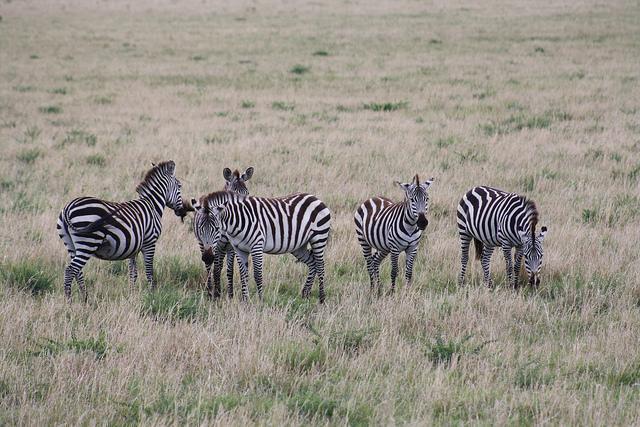How many zebras are standing in the middle of the open field?
Answer the question by selecting the correct answer among the 4 following choices and explain your choice with a short sentence. The answer should be formatted with the following format: `Answer: choice
Rationale: rationale.`
Options: Four, six, five, two. Answer: five.
Rationale: There are five zebras in the middle of the field and some are grazing. 